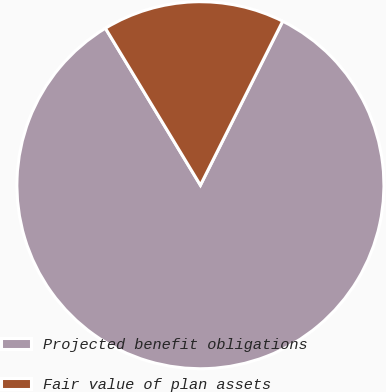Convert chart to OTSL. <chart><loc_0><loc_0><loc_500><loc_500><pie_chart><fcel>Projected benefit obligations<fcel>Fair value of plan assets<nl><fcel>83.94%<fcel>16.06%<nl></chart> 